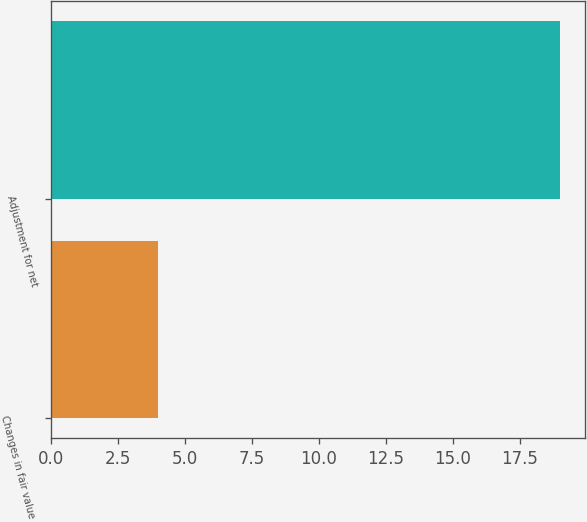<chart> <loc_0><loc_0><loc_500><loc_500><bar_chart><fcel>Changes in fair value of<fcel>Adjustment for net<nl><fcel>4<fcel>19<nl></chart> 